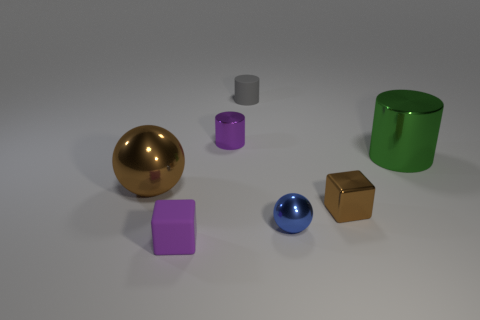Does the metallic cube have the same color as the big shiny ball? Yes, the metallic cube and the big shiny ball both exhibit a golden hue, reflecting their shared property of color. This similarity in coloration creates a visually cohesive element amidst the diverse array of objects present in the image. 